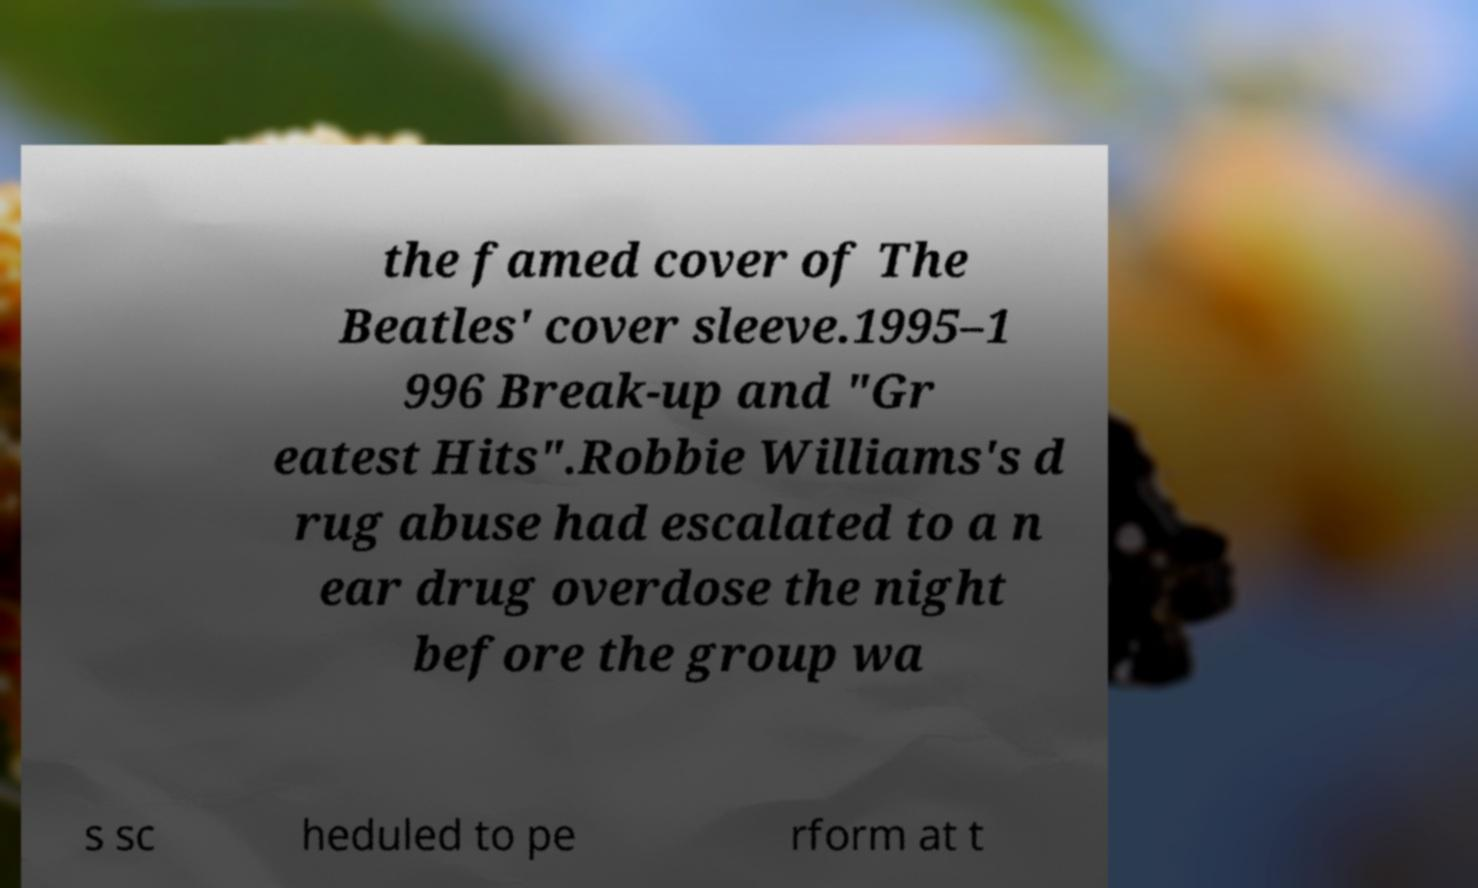Can you accurately transcribe the text from the provided image for me? the famed cover of The Beatles' cover sleeve.1995–1 996 Break-up and "Gr eatest Hits".Robbie Williams's d rug abuse had escalated to a n ear drug overdose the night before the group wa s sc heduled to pe rform at t 